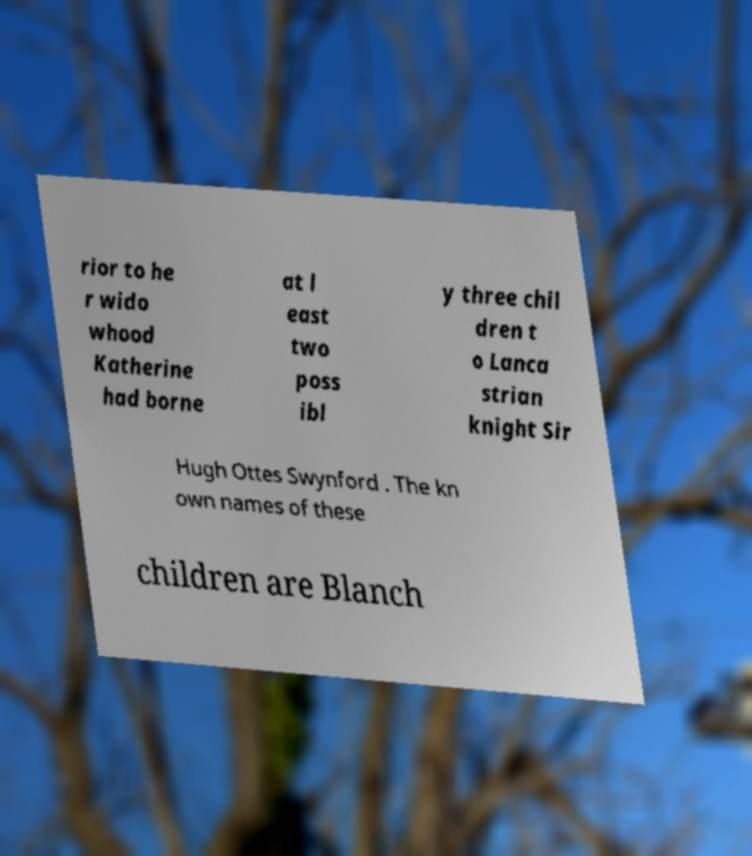What messages or text are displayed in this image? I need them in a readable, typed format. rior to he r wido whood Katherine had borne at l east two poss ibl y three chil dren t o Lanca strian knight Sir Hugh Ottes Swynford . The kn own names of these children are Blanch 